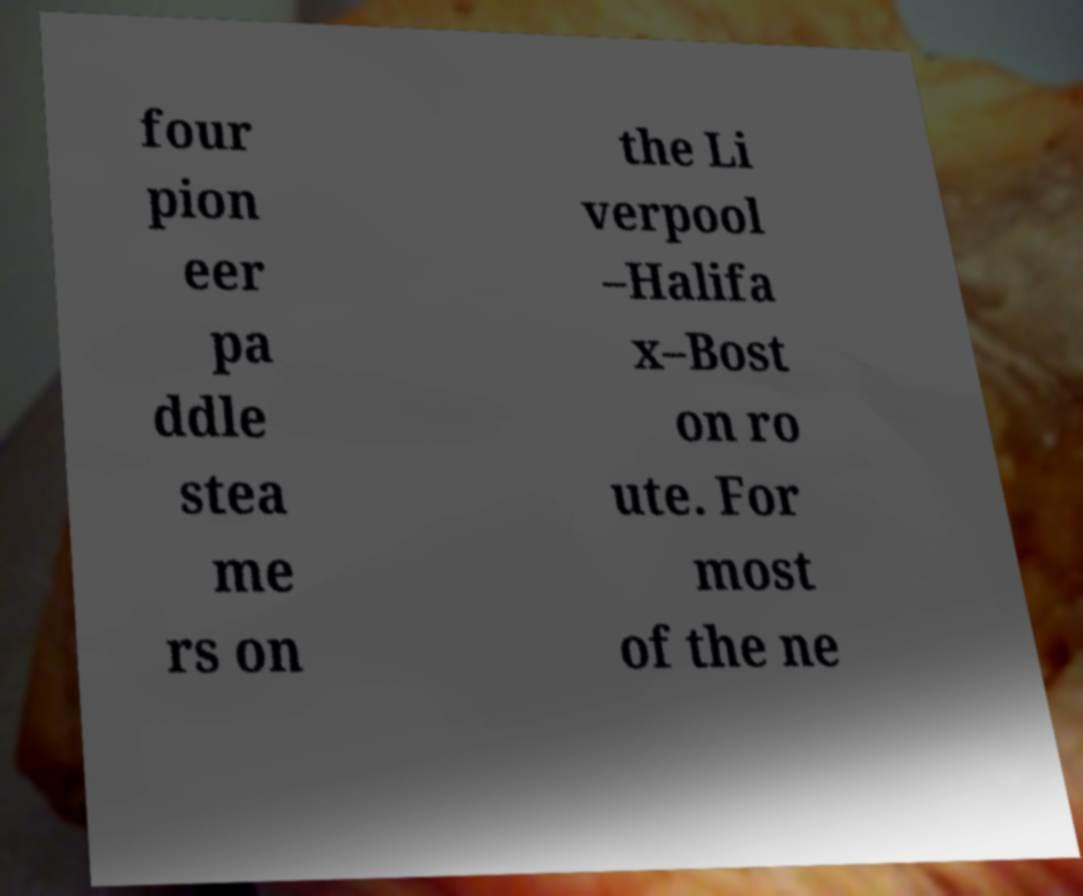Could you assist in decoding the text presented in this image and type it out clearly? four pion eer pa ddle stea me rs on the Li verpool –Halifa x–Bost on ro ute. For most of the ne 